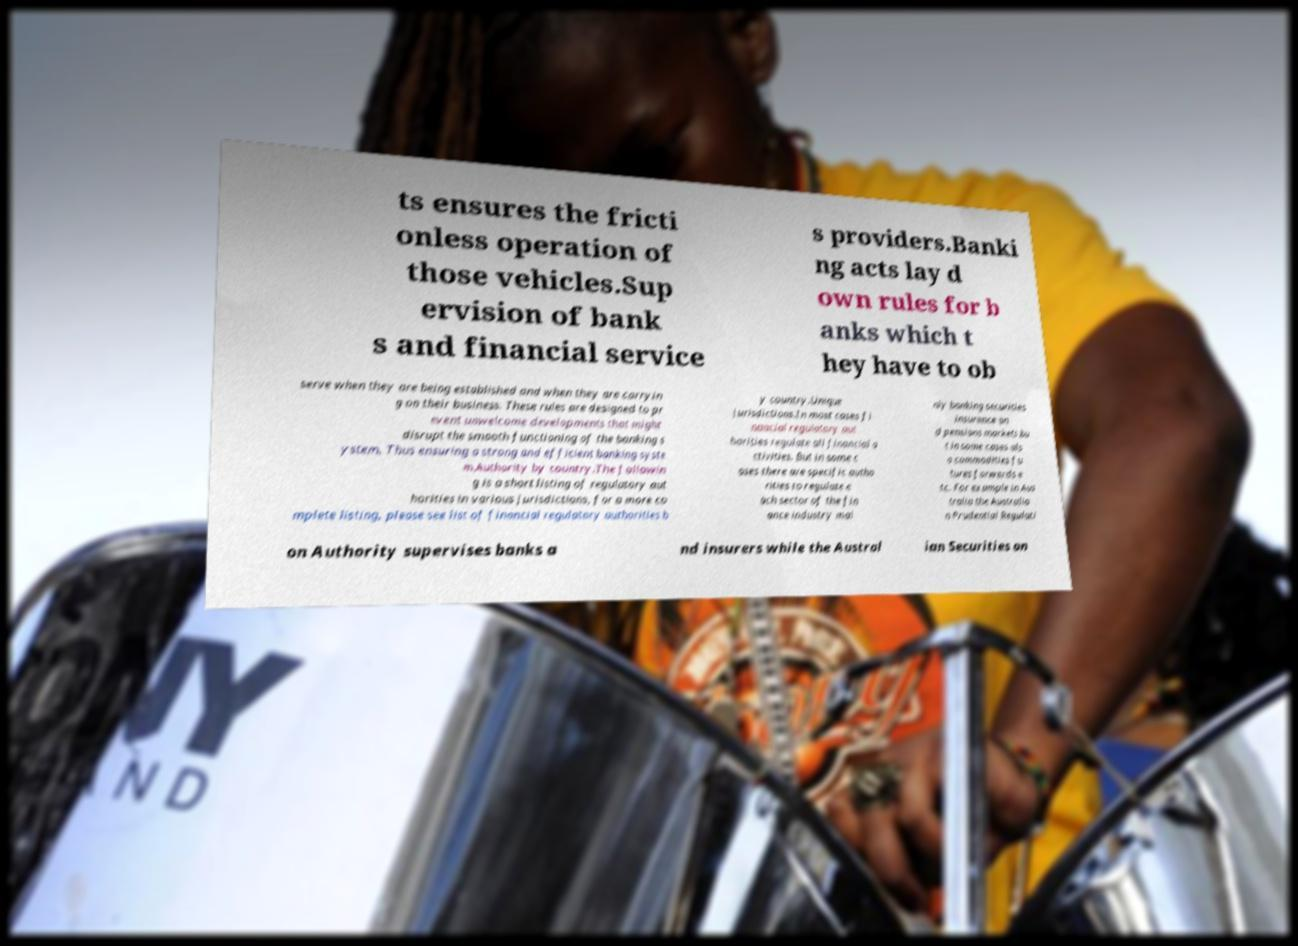Please read and relay the text visible in this image. What does it say? ts ensures the fricti onless operation of those vehicles.Sup ervision of bank s and financial service s providers.Banki ng acts lay d own rules for b anks which t hey have to ob serve when they are being established and when they are carryin g on their business. These rules are designed to pr event unwelcome developments that might disrupt the smooth functioning of the banking s ystem. Thus ensuring a strong and efficient banking syste m.Authority by country.The followin g is a short listing of regulatory aut horities in various jurisdictions, for a more co mplete listing, please see list of financial regulatory authorities b y country.Unique jurisdictions.In most cases fi nancial regulatory aut horities regulate all financial a ctivities. But in some c ases there are specific autho rities to regulate e ach sector of the fin ance industry mai nly banking securities insurance an d pensions markets bu t in some cases als o commodities fu tures forwards e tc. For example in Aus tralia the Australia n Prudential Regulati on Authority supervises banks a nd insurers while the Austral ian Securities an 